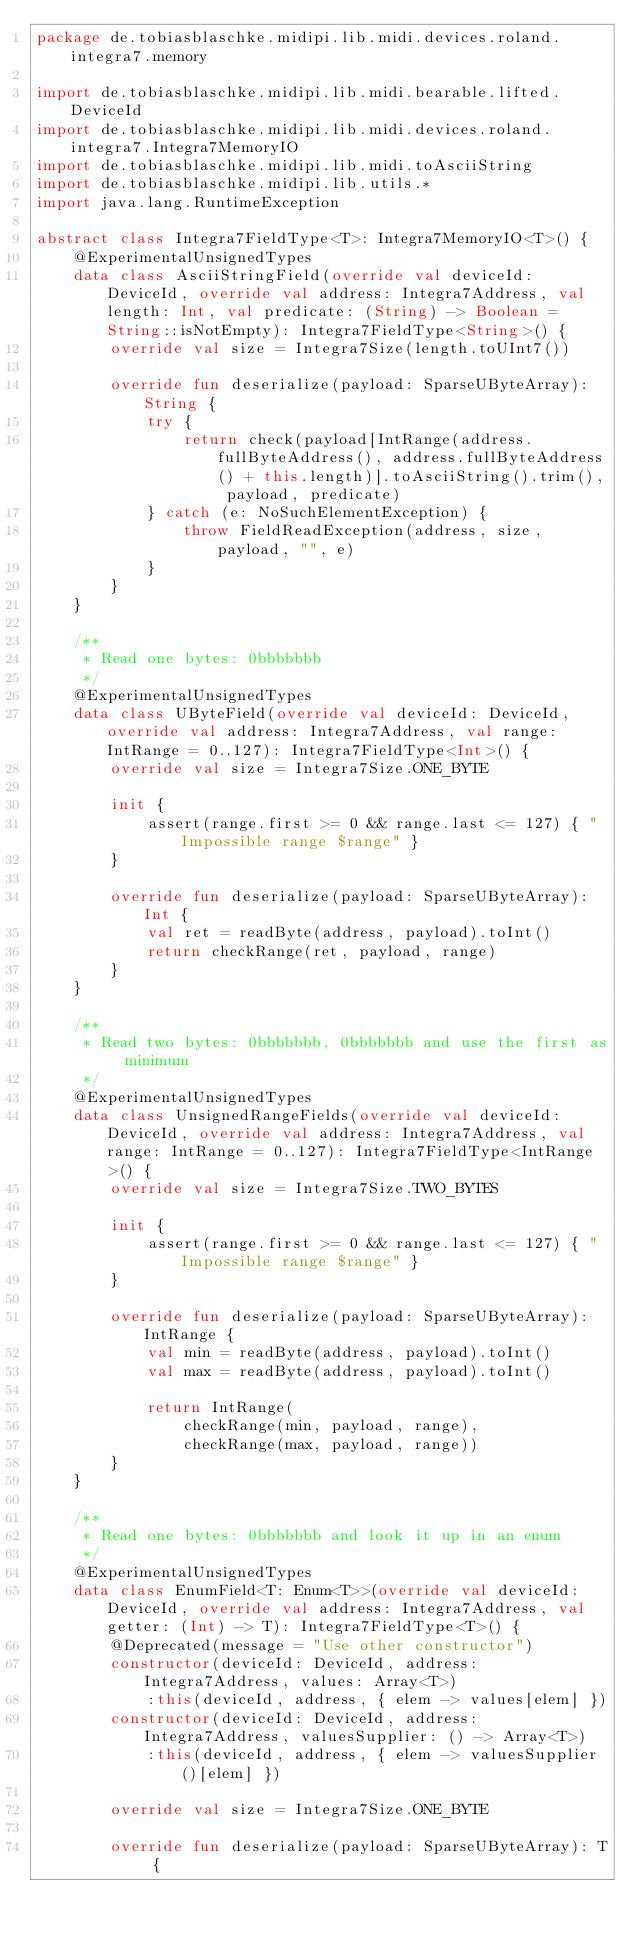<code> <loc_0><loc_0><loc_500><loc_500><_Kotlin_>package de.tobiasblaschke.midipi.lib.midi.devices.roland.integra7.memory

import de.tobiasblaschke.midipi.lib.midi.bearable.lifted.DeviceId
import de.tobiasblaschke.midipi.lib.midi.devices.roland.integra7.Integra7MemoryIO
import de.tobiasblaschke.midipi.lib.midi.toAsciiString
import de.tobiasblaschke.midipi.lib.utils.*
import java.lang.RuntimeException

abstract class Integra7FieldType<T>: Integra7MemoryIO<T>() {
    @ExperimentalUnsignedTypes
    data class AsciiStringField(override val deviceId: DeviceId, override val address: Integra7Address, val length: Int, val predicate: (String) -> Boolean = String::isNotEmpty): Integra7FieldType<String>() {
        override val size = Integra7Size(length.toUInt7())

        override fun deserialize(payload: SparseUByteArray): String {
            try {
                return check(payload[IntRange(address.fullByteAddress(), address.fullByteAddress() + this.length)].toAsciiString().trim(), payload, predicate)
            } catch (e: NoSuchElementException) {
                throw FieldReadException(address, size, payload, "", e)
            }
        }
    }

    /**
     * Read one bytes: 0bbbbbbb
     */
    @ExperimentalUnsignedTypes
    data class UByteField(override val deviceId: DeviceId, override val address: Integra7Address, val range: IntRange = 0..127): Integra7FieldType<Int>() {
        override val size = Integra7Size.ONE_BYTE

        init {
            assert(range.first >= 0 && range.last <= 127) { "Impossible range $range" }
        }

        override fun deserialize(payload: SparseUByteArray): Int {
            val ret = readByte(address, payload).toInt()
            return checkRange(ret, payload, range)
        }
    }

    /**
     * Read two bytes: 0bbbbbbb, 0bbbbbbb and use the first as minimum
     */
    @ExperimentalUnsignedTypes
    data class UnsignedRangeFields(override val deviceId: DeviceId, override val address: Integra7Address, val range: IntRange = 0..127): Integra7FieldType<IntRange>() {
        override val size = Integra7Size.TWO_BYTES

        init {
            assert(range.first >= 0 && range.last <= 127) { "Impossible range $range" }
        }

        override fun deserialize(payload: SparseUByteArray): IntRange {
            val min = readByte(address, payload).toInt()
            val max = readByte(address, payload).toInt()

            return IntRange(
                checkRange(min, payload, range),
                checkRange(max, payload, range))
        }
    }

    /**
     * Read one bytes: 0bbbbbbb and look it up in an enum
     */
    @ExperimentalUnsignedTypes
    data class EnumField<T: Enum<T>>(override val deviceId: DeviceId, override val address: Integra7Address, val getter: (Int) -> T): Integra7FieldType<T>() {
        @Deprecated(message = "Use other constructor")
        constructor(deviceId: DeviceId, address: Integra7Address, values: Array<T>)
            :this(deviceId, address, { elem -> values[elem] })
        constructor(deviceId: DeviceId, address: Integra7Address, valuesSupplier: () -> Array<T>)
            :this(deviceId, address, { elem -> valuesSupplier()[elem] })

        override val size = Integra7Size.ONE_BYTE

        override fun deserialize(payload: SparseUByteArray): T {</code> 